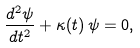<formula> <loc_0><loc_0><loc_500><loc_500>\frac { d ^ { 2 } \psi } { d t ^ { 2 } } + \kappa ( t ) \, \psi = 0 ,</formula> 